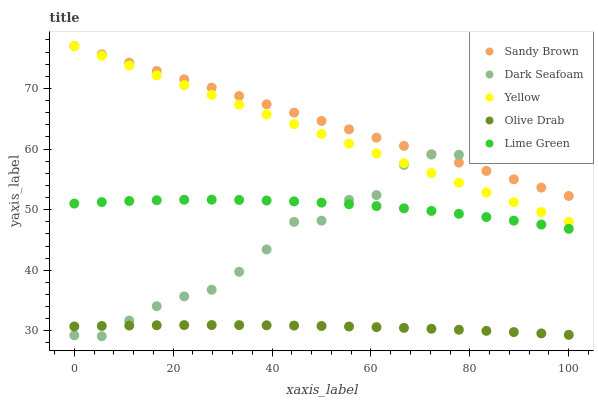Does Olive Drab have the minimum area under the curve?
Answer yes or no. Yes. Does Sandy Brown have the maximum area under the curve?
Answer yes or no. Yes. Does Dark Seafoam have the minimum area under the curve?
Answer yes or no. No. Does Dark Seafoam have the maximum area under the curve?
Answer yes or no. No. Is Sandy Brown the smoothest?
Answer yes or no. Yes. Is Dark Seafoam the roughest?
Answer yes or no. Yes. Is Dark Seafoam the smoothest?
Answer yes or no. No. Is Sandy Brown the roughest?
Answer yes or no. No. Does Dark Seafoam have the lowest value?
Answer yes or no. Yes. Does Sandy Brown have the lowest value?
Answer yes or no. No. Does Yellow have the highest value?
Answer yes or no. Yes. Does Dark Seafoam have the highest value?
Answer yes or no. No. Is Lime Green less than Sandy Brown?
Answer yes or no. Yes. Is Sandy Brown greater than Lime Green?
Answer yes or no. Yes. Does Dark Seafoam intersect Lime Green?
Answer yes or no. Yes. Is Dark Seafoam less than Lime Green?
Answer yes or no. No. Is Dark Seafoam greater than Lime Green?
Answer yes or no. No. Does Lime Green intersect Sandy Brown?
Answer yes or no. No. 